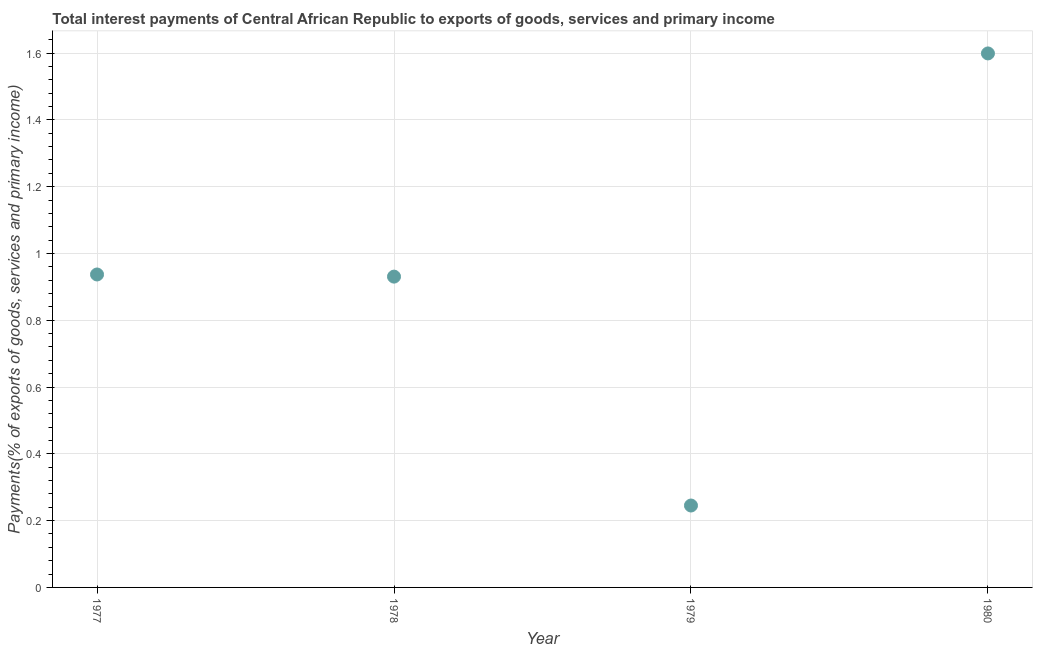What is the total interest payments on external debt in 1979?
Provide a succinct answer. 0.25. Across all years, what is the maximum total interest payments on external debt?
Offer a terse response. 1.6. Across all years, what is the minimum total interest payments on external debt?
Your response must be concise. 0.25. In which year was the total interest payments on external debt maximum?
Your response must be concise. 1980. In which year was the total interest payments on external debt minimum?
Your answer should be very brief. 1979. What is the sum of the total interest payments on external debt?
Your response must be concise. 3.71. What is the difference between the total interest payments on external debt in 1977 and 1980?
Keep it short and to the point. -0.66. What is the average total interest payments on external debt per year?
Ensure brevity in your answer.  0.93. What is the median total interest payments on external debt?
Your response must be concise. 0.93. What is the ratio of the total interest payments on external debt in 1978 to that in 1980?
Provide a short and direct response. 0.58. Is the difference between the total interest payments on external debt in 1978 and 1980 greater than the difference between any two years?
Give a very brief answer. No. What is the difference between the highest and the second highest total interest payments on external debt?
Your response must be concise. 0.66. Is the sum of the total interest payments on external debt in 1977 and 1979 greater than the maximum total interest payments on external debt across all years?
Offer a very short reply. No. What is the difference between the highest and the lowest total interest payments on external debt?
Ensure brevity in your answer.  1.35. Does the total interest payments on external debt monotonically increase over the years?
Provide a succinct answer. No. How many years are there in the graph?
Offer a terse response. 4. Does the graph contain any zero values?
Offer a very short reply. No. Does the graph contain grids?
Your answer should be very brief. Yes. What is the title of the graph?
Your answer should be compact. Total interest payments of Central African Republic to exports of goods, services and primary income. What is the label or title of the Y-axis?
Provide a short and direct response. Payments(% of exports of goods, services and primary income). What is the Payments(% of exports of goods, services and primary income) in 1977?
Ensure brevity in your answer.  0.94. What is the Payments(% of exports of goods, services and primary income) in 1978?
Offer a very short reply. 0.93. What is the Payments(% of exports of goods, services and primary income) in 1979?
Offer a very short reply. 0.25. What is the Payments(% of exports of goods, services and primary income) in 1980?
Ensure brevity in your answer.  1.6. What is the difference between the Payments(% of exports of goods, services and primary income) in 1977 and 1978?
Offer a terse response. 0.01. What is the difference between the Payments(% of exports of goods, services and primary income) in 1977 and 1979?
Offer a terse response. 0.69. What is the difference between the Payments(% of exports of goods, services and primary income) in 1977 and 1980?
Your answer should be very brief. -0.66. What is the difference between the Payments(% of exports of goods, services and primary income) in 1978 and 1979?
Provide a succinct answer. 0.69. What is the difference between the Payments(% of exports of goods, services and primary income) in 1978 and 1980?
Make the answer very short. -0.67. What is the difference between the Payments(% of exports of goods, services and primary income) in 1979 and 1980?
Offer a very short reply. -1.35. What is the ratio of the Payments(% of exports of goods, services and primary income) in 1977 to that in 1979?
Ensure brevity in your answer.  3.82. What is the ratio of the Payments(% of exports of goods, services and primary income) in 1977 to that in 1980?
Give a very brief answer. 0.59. What is the ratio of the Payments(% of exports of goods, services and primary income) in 1978 to that in 1979?
Make the answer very short. 3.79. What is the ratio of the Payments(% of exports of goods, services and primary income) in 1978 to that in 1980?
Give a very brief answer. 0.58. What is the ratio of the Payments(% of exports of goods, services and primary income) in 1979 to that in 1980?
Ensure brevity in your answer.  0.15. 